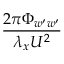Convert formula to latex. <formula><loc_0><loc_0><loc_500><loc_500>\frac { 2 \pi \Phi _ { w ^ { \prime } w ^ { \prime } } } { \lambda _ { x } U ^ { 2 } }</formula> 